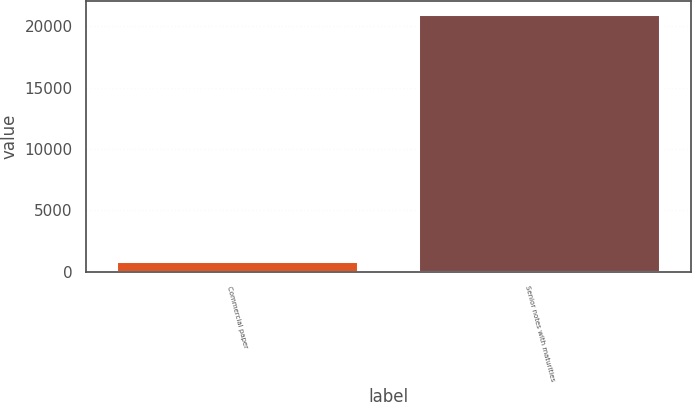Convert chart. <chart><loc_0><loc_0><loc_500><loc_500><bar_chart><fcel>Commercial paper<fcel>Senior notes with maturities<nl><fcel>845<fcel>20989<nl></chart> 